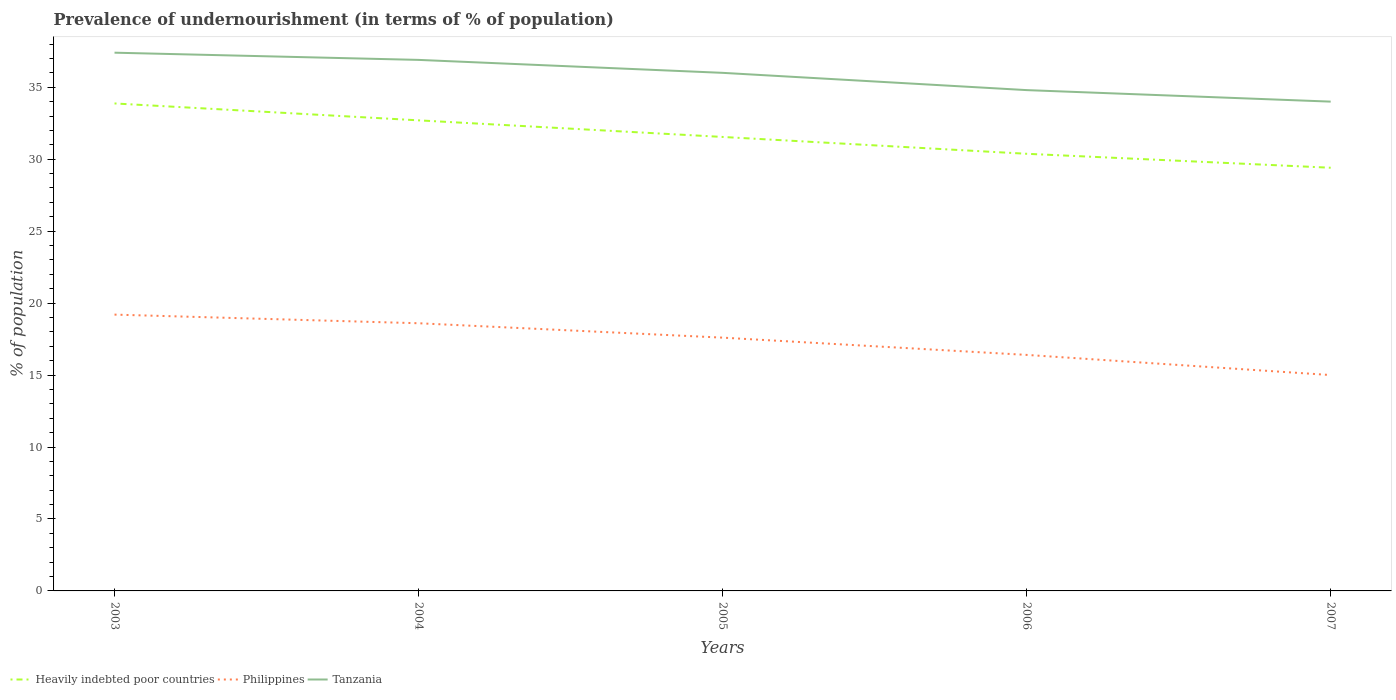Does the line corresponding to Tanzania intersect with the line corresponding to Philippines?
Offer a terse response. No. Is the number of lines equal to the number of legend labels?
Your response must be concise. Yes. Across all years, what is the maximum percentage of undernourished population in Philippines?
Keep it short and to the point. 15. What is the total percentage of undernourished population in Tanzania in the graph?
Give a very brief answer. 1.4. What is the difference between the highest and the second highest percentage of undernourished population in Tanzania?
Give a very brief answer. 3.4. What is the difference between the highest and the lowest percentage of undernourished population in Philippines?
Provide a succinct answer. 3. How many years are there in the graph?
Your answer should be compact. 5. What is the difference between two consecutive major ticks on the Y-axis?
Your response must be concise. 5. Are the values on the major ticks of Y-axis written in scientific E-notation?
Your answer should be compact. No. Does the graph contain any zero values?
Your answer should be very brief. No. Does the graph contain grids?
Provide a succinct answer. No. Where does the legend appear in the graph?
Ensure brevity in your answer.  Bottom left. How many legend labels are there?
Keep it short and to the point. 3. How are the legend labels stacked?
Ensure brevity in your answer.  Horizontal. What is the title of the graph?
Your answer should be very brief. Prevalence of undernourishment (in terms of % of population). Does "Kosovo" appear as one of the legend labels in the graph?
Make the answer very short. No. What is the label or title of the Y-axis?
Provide a succinct answer. % of population. What is the % of population in Heavily indebted poor countries in 2003?
Give a very brief answer. 33.87. What is the % of population of Philippines in 2003?
Offer a very short reply. 19.2. What is the % of population of Tanzania in 2003?
Your response must be concise. 37.4. What is the % of population of Heavily indebted poor countries in 2004?
Your answer should be very brief. 32.7. What is the % of population of Philippines in 2004?
Ensure brevity in your answer.  18.6. What is the % of population in Tanzania in 2004?
Your response must be concise. 36.9. What is the % of population of Heavily indebted poor countries in 2005?
Your response must be concise. 31.55. What is the % of population of Heavily indebted poor countries in 2006?
Ensure brevity in your answer.  30.38. What is the % of population in Tanzania in 2006?
Offer a very short reply. 34.8. What is the % of population of Heavily indebted poor countries in 2007?
Your response must be concise. 29.41. What is the % of population in Tanzania in 2007?
Your response must be concise. 34. Across all years, what is the maximum % of population in Heavily indebted poor countries?
Make the answer very short. 33.87. Across all years, what is the maximum % of population of Philippines?
Provide a succinct answer. 19.2. Across all years, what is the maximum % of population in Tanzania?
Your answer should be very brief. 37.4. Across all years, what is the minimum % of population of Heavily indebted poor countries?
Offer a terse response. 29.41. Across all years, what is the minimum % of population in Tanzania?
Offer a very short reply. 34. What is the total % of population in Heavily indebted poor countries in the graph?
Offer a very short reply. 157.9. What is the total % of population of Philippines in the graph?
Provide a succinct answer. 86.8. What is the total % of population of Tanzania in the graph?
Your answer should be very brief. 179.1. What is the difference between the % of population in Heavily indebted poor countries in 2003 and that in 2004?
Offer a terse response. 1.17. What is the difference between the % of population of Heavily indebted poor countries in 2003 and that in 2005?
Ensure brevity in your answer.  2.33. What is the difference between the % of population in Tanzania in 2003 and that in 2005?
Provide a succinct answer. 1.4. What is the difference between the % of population of Heavily indebted poor countries in 2003 and that in 2006?
Provide a succinct answer. 3.5. What is the difference between the % of population in Heavily indebted poor countries in 2003 and that in 2007?
Your answer should be very brief. 4.47. What is the difference between the % of population in Philippines in 2003 and that in 2007?
Give a very brief answer. 4.2. What is the difference between the % of population in Tanzania in 2003 and that in 2007?
Provide a short and direct response. 3.4. What is the difference between the % of population in Heavily indebted poor countries in 2004 and that in 2005?
Ensure brevity in your answer.  1.15. What is the difference between the % of population in Philippines in 2004 and that in 2005?
Provide a short and direct response. 1. What is the difference between the % of population in Tanzania in 2004 and that in 2005?
Your response must be concise. 0.9. What is the difference between the % of population in Heavily indebted poor countries in 2004 and that in 2006?
Your response must be concise. 2.32. What is the difference between the % of population in Philippines in 2004 and that in 2006?
Your answer should be compact. 2.2. What is the difference between the % of population in Tanzania in 2004 and that in 2006?
Your answer should be compact. 2.1. What is the difference between the % of population of Heavily indebted poor countries in 2004 and that in 2007?
Offer a terse response. 3.29. What is the difference between the % of population in Tanzania in 2004 and that in 2007?
Keep it short and to the point. 2.9. What is the difference between the % of population in Heavily indebted poor countries in 2005 and that in 2006?
Make the answer very short. 1.17. What is the difference between the % of population of Philippines in 2005 and that in 2006?
Ensure brevity in your answer.  1.2. What is the difference between the % of population in Tanzania in 2005 and that in 2006?
Offer a terse response. 1.2. What is the difference between the % of population in Heavily indebted poor countries in 2005 and that in 2007?
Provide a short and direct response. 2.14. What is the difference between the % of population in Tanzania in 2005 and that in 2007?
Your answer should be compact. 2. What is the difference between the % of population in Heavily indebted poor countries in 2006 and that in 2007?
Provide a short and direct response. 0.97. What is the difference between the % of population in Philippines in 2006 and that in 2007?
Provide a succinct answer. 1.4. What is the difference between the % of population in Tanzania in 2006 and that in 2007?
Ensure brevity in your answer.  0.8. What is the difference between the % of population in Heavily indebted poor countries in 2003 and the % of population in Philippines in 2004?
Your answer should be compact. 15.27. What is the difference between the % of population of Heavily indebted poor countries in 2003 and the % of population of Tanzania in 2004?
Ensure brevity in your answer.  -3.03. What is the difference between the % of population of Philippines in 2003 and the % of population of Tanzania in 2004?
Your answer should be compact. -17.7. What is the difference between the % of population of Heavily indebted poor countries in 2003 and the % of population of Philippines in 2005?
Your answer should be very brief. 16.27. What is the difference between the % of population in Heavily indebted poor countries in 2003 and the % of population in Tanzania in 2005?
Provide a short and direct response. -2.13. What is the difference between the % of population of Philippines in 2003 and the % of population of Tanzania in 2005?
Offer a very short reply. -16.8. What is the difference between the % of population in Heavily indebted poor countries in 2003 and the % of population in Philippines in 2006?
Keep it short and to the point. 17.47. What is the difference between the % of population in Heavily indebted poor countries in 2003 and the % of population in Tanzania in 2006?
Make the answer very short. -0.93. What is the difference between the % of population in Philippines in 2003 and the % of population in Tanzania in 2006?
Your answer should be compact. -15.6. What is the difference between the % of population in Heavily indebted poor countries in 2003 and the % of population in Philippines in 2007?
Offer a terse response. 18.87. What is the difference between the % of population in Heavily indebted poor countries in 2003 and the % of population in Tanzania in 2007?
Provide a short and direct response. -0.13. What is the difference between the % of population of Philippines in 2003 and the % of population of Tanzania in 2007?
Provide a short and direct response. -14.8. What is the difference between the % of population of Heavily indebted poor countries in 2004 and the % of population of Philippines in 2005?
Your answer should be compact. 15.1. What is the difference between the % of population in Heavily indebted poor countries in 2004 and the % of population in Tanzania in 2005?
Offer a very short reply. -3.3. What is the difference between the % of population of Philippines in 2004 and the % of population of Tanzania in 2005?
Offer a very short reply. -17.4. What is the difference between the % of population in Heavily indebted poor countries in 2004 and the % of population in Philippines in 2006?
Offer a terse response. 16.3. What is the difference between the % of population in Heavily indebted poor countries in 2004 and the % of population in Tanzania in 2006?
Offer a very short reply. -2.1. What is the difference between the % of population of Philippines in 2004 and the % of population of Tanzania in 2006?
Keep it short and to the point. -16.2. What is the difference between the % of population in Heavily indebted poor countries in 2004 and the % of population in Philippines in 2007?
Give a very brief answer. 17.7. What is the difference between the % of population of Heavily indebted poor countries in 2004 and the % of population of Tanzania in 2007?
Offer a very short reply. -1.3. What is the difference between the % of population of Philippines in 2004 and the % of population of Tanzania in 2007?
Keep it short and to the point. -15.4. What is the difference between the % of population in Heavily indebted poor countries in 2005 and the % of population in Philippines in 2006?
Ensure brevity in your answer.  15.15. What is the difference between the % of population of Heavily indebted poor countries in 2005 and the % of population of Tanzania in 2006?
Make the answer very short. -3.25. What is the difference between the % of population of Philippines in 2005 and the % of population of Tanzania in 2006?
Offer a very short reply. -17.2. What is the difference between the % of population in Heavily indebted poor countries in 2005 and the % of population in Philippines in 2007?
Keep it short and to the point. 16.55. What is the difference between the % of population in Heavily indebted poor countries in 2005 and the % of population in Tanzania in 2007?
Ensure brevity in your answer.  -2.45. What is the difference between the % of population in Philippines in 2005 and the % of population in Tanzania in 2007?
Give a very brief answer. -16.4. What is the difference between the % of population of Heavily indebted poor countries in 2006 and the % of population of Philippines in 2007?
Your answer should be very brief. 15.38. What is the difference between the % of population in Heavily indebted poor countries in 2006 and the % of population in Tanzania in 2007?
Provide a short and direct response. -3.62. What is the difference between the % of population of Philippines in 2006 and the % of population of Tanzania in 2007?
Offer a very short reply. -17.6. What is the average % of population in Heavily indebted poor countries per year?
Provide a short and direct response. 31.58. What is the average % of population of Philippines per year?
Your response must be concise. 17.36. What is the average % of population in Tanzania per year?
Provide a succinct answer. 35.82. In the year 2003, what is the difference between the % of population of Heavily indebted poor countries and % of population of Philippines?
Ensure brevity in your answer.  14.67. In the year 2003, what is the difference between the % of population of Heavily indebted poor countries and % of population of Tanzania?
Make the answer very short. -3.53. In the year 2003, what is the difference between the % of population in Philippines and % of population in Tanzania?
Make the answer very short. -18.2. In the year 2004, what is the difference between the % of population in Heavily indebted poor countries and % of population in Philippines?
Your response must be concise. 14.1. In the year 2004, what is the difference between the % of population in Heavily indebted poor countries and % of population in Tanzania?
Ensure brevity in your answer.  -4.2. In the year 2004, what is the difference between the % of population in Philippines and % of population in Tanzania?
Offer a very short reply. -18.3. In the year 2005, what is the difference between the % of population of Heavily indebted poor countries and % of population of Philippines?
Provide a succinct answer. 13.95. In the year 2005, what is the difference between the % of population in Heavily indebted poor countries and % of population in Tanzania?
Your answer should be very brief. -4.45. In the year 2005, what is the difference between the % of population in Philippines and % of population in Tanzania?
Keep it short and to the point. -18.4. In the year 2006, what is the difference between the % of population in Heavily indebted poor countries and % of population in Philippines?
Provide a short and direct response. 13.98. In the year 2006, what is the difference between the % of population in Heavily indebted poor countries and % of population in Tanzania?
Make the answer very short. -4.42. In the year 2006, what is the difference between the % of population of Philippines and % of population of Tanzania?
Keep it short and to the point. -18.4. In the year 2007, what is the difference between the % of population of Heavily indebted poor countries and % of population of Philippines?
Your answer should be very brief. 14.41. In the year 2007, what is the difference between the % of population of Heavily indebted poor countries and % of population of Tanzania?
Ensure brevity in your answer.  -4.59. In the year 2007, what is the difference between the % of population of Philippines and % of population of Tanzania?
Offer a terse response. -19. What is the ratio of the % of population in Heavily indebted poor countries in 2003 to that in 2004?
Keep it short and to the point. 1.04. What is the ratio of the % of population of Philippines in 2003 to that in 2004?
Give a very brief answer. 1.03. What is the ratio of the % of population of Tanzania in 2003 to that in 2004?
Your response must be concise. 1.01. What is the ratio of the % of population of Heavily indebted poor countries in 2003 to that in 2005?
Offer a terse response. 1.07. What is the ratio of the % of population of Philippines in 2003 to that in 2005?
Your response must be concise. 1.09. What is the ratio of the % of population in Tanzania in 2003 to that in 2005?
Offer a terse response. 1.04. What is the ratio of the % of population in Heavily indebted poor countries in 2003 to that in 2006?
Ensure brevity in your answer.  1.12. What is the ratio of the % of population of Philippines in 2003 to that in 2006?
Make the answer very short. 1.17. What is the ratio of the % of population in Tanzania in 2003 to that in 2006?
Your response must be concise. 1.07. What is the ratio of the % of population in Heavily indebted poor countries in 2003 to that in 2007?
Your answer should be compact. 1.15. What is the ratio of the % of population of Philippines in 2003 to that in 2007?
Your answer should be compact. 1.28. What is the ratio of the % of population of Tanzania in 2003 to that in 2007?
Your response must be concise. 1.1. What is the ratio of the % of population of Heavily indebted poor countries in 2004 to that in 2005?
Offer a very short reply. 1.04. What is the ratio of the % of population of Philippines in 2004 to that in 2005?
Ensure brevity in your answer.  1.06. What is the ratio of the % of population of Heavily indebted poor countries in 2004 to that in 2006?
Provide a succinct answer. 1.08. What is the ratio of the % of population of Philippines in 2004 to that in 2006?
Your answer should be very brief. 1.13. What is the ratio of the % of population of Tanzania in 2004 to that in 2006?
Your response must be concise. 1.06. What is the ratio of the % of population of Heavily indebted poor countries in 2004 to that in 2007?
Provide a succinct answer. 1.11. What is the ratio of the % of population in Philippines in 2004 to that in 2007?
Your answer should be very brief. 1.24. What is the ratio of the % of population in Tanzania in 2004 to that in 2007?
Your answer should be very brief. 1.09. What is the ratio of the % of population of Philippines in 2005 to that in 2006?
Keep it short and to the point. 1.07. What is the ratio of the % of population in Tanzania in 2005 to that in 2006?
Provide a short and direct response. 1.03. What is the ratio of the % of population in Heavily indebted poor countries in 2005 to that in 2007?
Keep it short and to the point. 1.07. What is the ratio of the % of population in Philippines in 2005 to that in 2007?
Your response must be concise. 1.17. What is the ratio of the % of population of Tanzania in 2005 to that in 2007?
Keep it short and to the point. 1.06. What is the ratio of the % of population of Heavily indebted poor countries in 2006 to that in 2007?
Offer a terse response. 1.03. What is the ratio of the % of population of Philippines in 2006 to that in 2007?
Your answer should be compact. 1.09. What is the ratio of the % of population in Tanzania in 2006 to that in 2007?
Your answer should be very brief. 1.02. What is the difference between the highest and the second highest % of population of Heavily indebted poor countries?
Offer a very short reply. 1.17. What is the difference between the highest and the second highest % of population in Philippines?
Your response must be concise. 0.6. What is the difference between the highest and the second highest % of population of Tanzania?
Give a very brief answer. 0.5. What is the difference between the highest and the lowest % of population of Heavily indebted poor countries?
Your answer should be very brief. 4.47. 